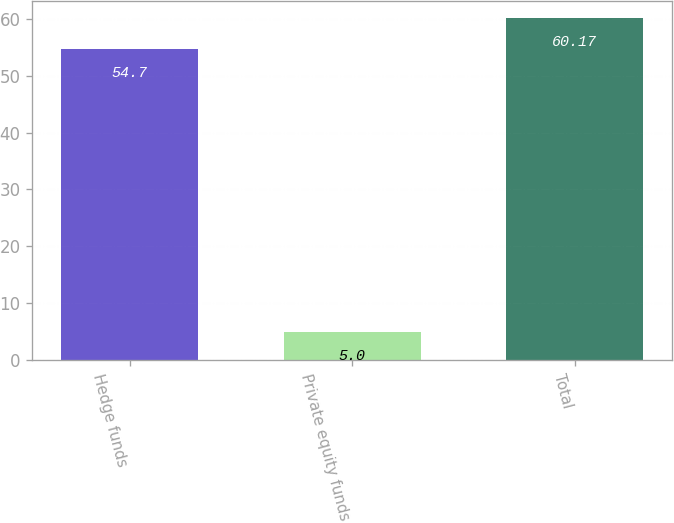Convert chart to OTSL. <chart><loc_0><loc_0><loc_500><loc_500><bar_chart><fcel>Hedge funds<fcel>Private equity funds<fcel>Total<nl><fcel>54.7<fcel>5<fcel>60.17<nl></chart> 